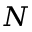<formula> <loc_0><loc_0><loc_500><loc_500>N</formula> 